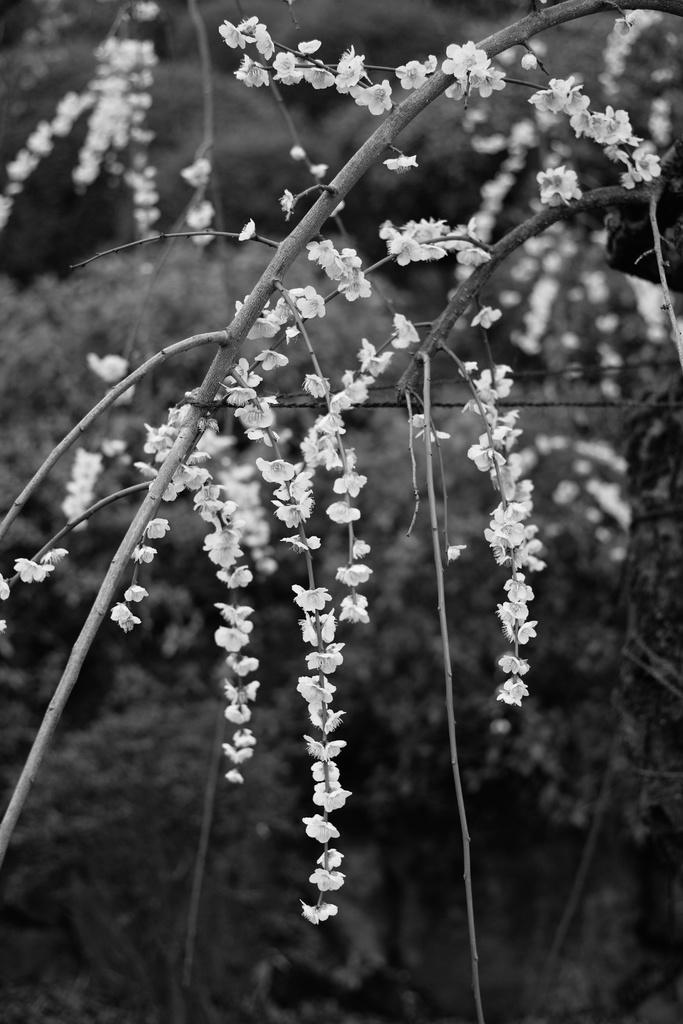What is the main subject of the image? There is a plant in the image. What color are the flowers on the plant? The plant has white flowers. Can you describe the background of the image? The background of the image is blurred. How many pages does the mother turn in the image? There is no reference to pages or a mother in the image; it features a plant with white flowers and a blurred background. 